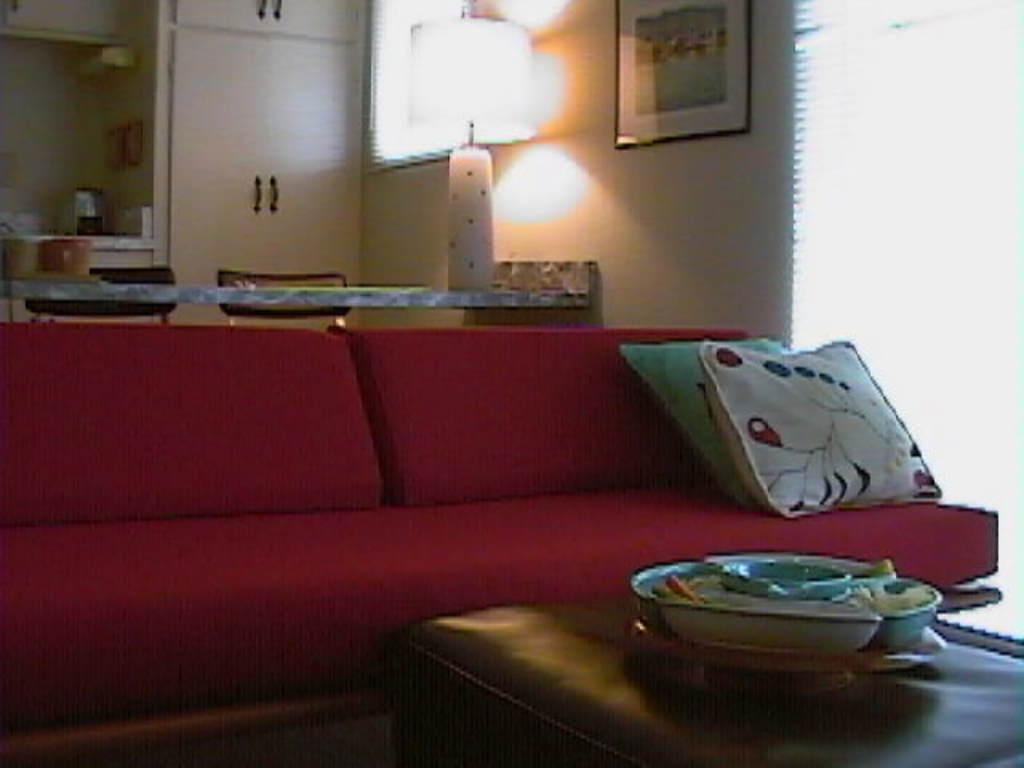Can you describe this image briefly? there is a living room sofa table different different items are present. 